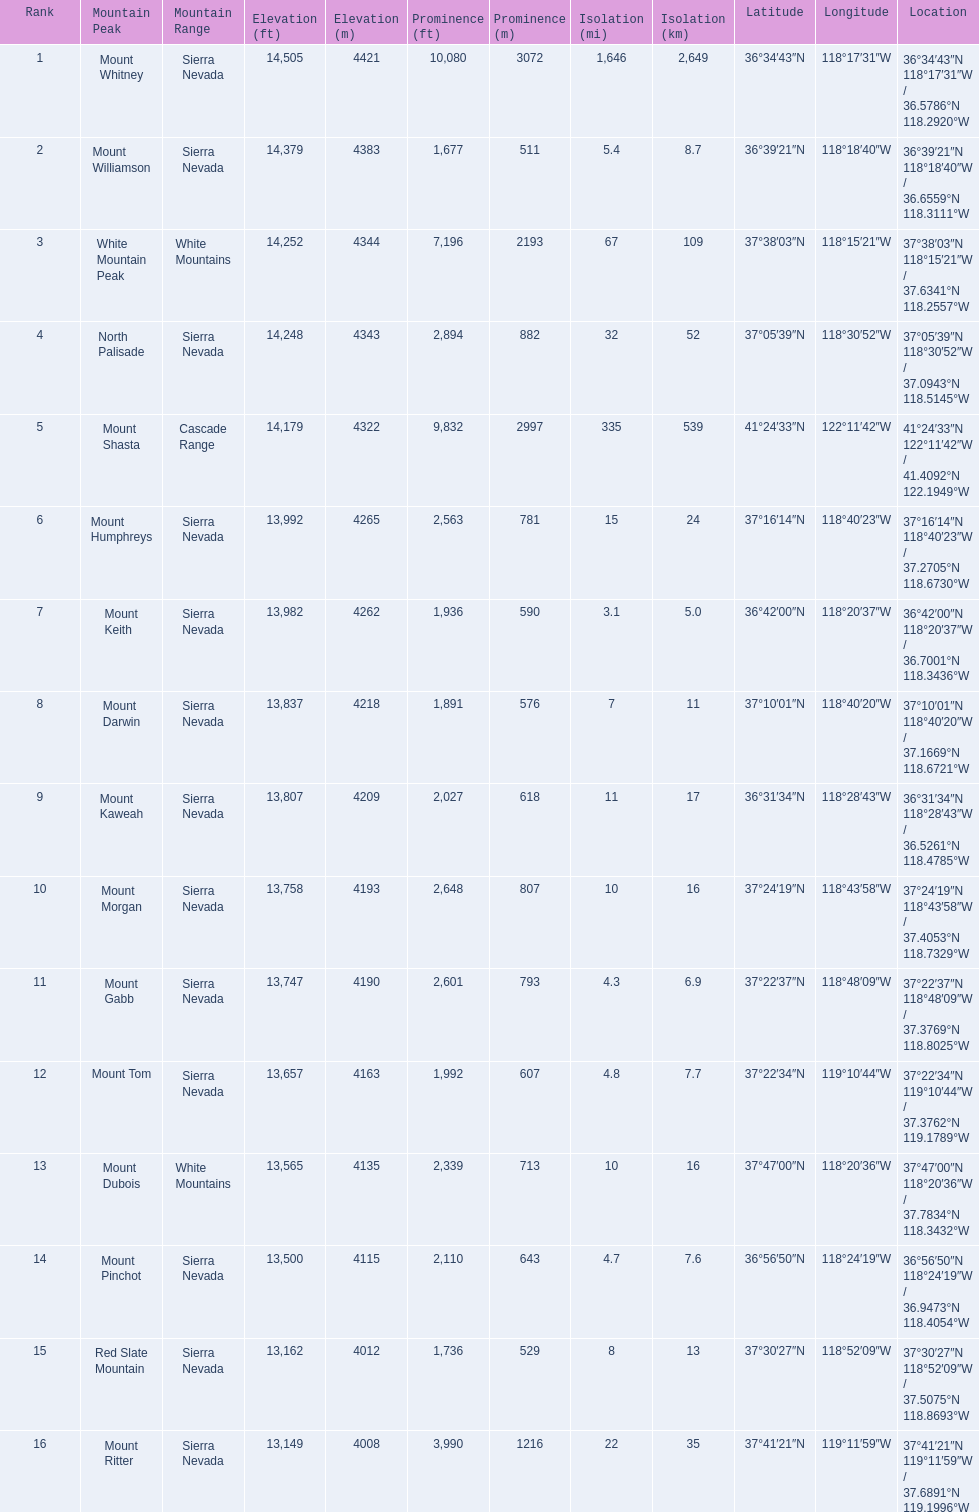What are the peaks in california? Mount Whitney, Mount Williamson, White Mountain Peak, North Palisade, Mount Shasta, Mount Humphreys, Mount Keith, Mount Darwin, Mount Kaweah, Mount Morgan, Mount Gabb, Mount Tom, Mount Dubois, Mount Pinchot, Red Slate Mountain, Mount Ritter. What are the peaks in sierra nevada, california? Mount Whitney, Mount Williamson, North Palisade, Mount Humphreys, Mount Keith, Mount Darwin, Mount Kaweah, Mount Morgan, Mount Gabb, Mount Tom, Mount Pinchot, Red Slate Mountain, Mount Ritter. What are the heights of the peaks in sierra nevada? 14,505 ft\n4421 m, 14,379 ft\n4383 m, 14,248 ft\n4343 m, 13,992 ft\n4265 m, 13,982 ft\n4262 m, 13,837 ft\n4218 m, 13,807 ft\n4209 m, 13,758 ft\n4193 m, 13,747 ft\n4190 m, 13,657 ft\n4163 m, 13,500 ft\n4115 m, 13,162 ft\n4012 m, 13,149 ft\n4008 m. Which is the highest? Mount Whitney. 